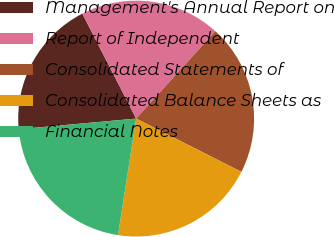Convert chart. <chart><loc_0><loc_0><loc_500><loc_500><pie_chart><fcel>Management's Annual Report on<fcel>Report of Independent<fcel>Consolidated Statements of<fcel>Consolidated Balance Sheets as<fcel>Financial Notes<nl><fcel>18.89%<fcel>19.26%<fcel>20.74%<fcel>20.0%<fcel>21.11%<nl></chart> 